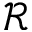<formula> <loc_0><loc_0><loc_500><loc_500>\mathcal { R }</formula> 